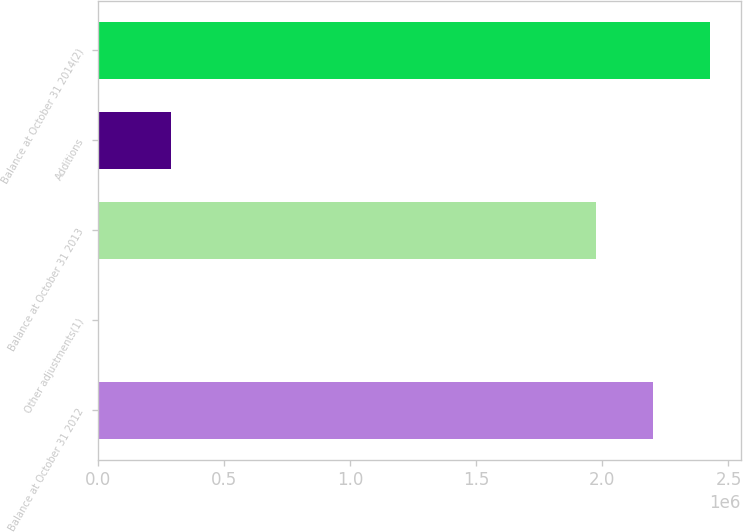Convert chart to OTSL. <chart><loc_0><loc_0><loc_500><loc_500><bar_chart><fcel>Balance at October 31 2012<fcel>Other adjustments(1)<fcel>Balance at October 31 2013<fcel>Additions<fcel>Balance at October 31 2014(2)<nl><fcel>2.20144e+06<fcel>1016<fcel>1.97597e+06<fcel>290379<fcel>2.42691e+06<nl></chart> 